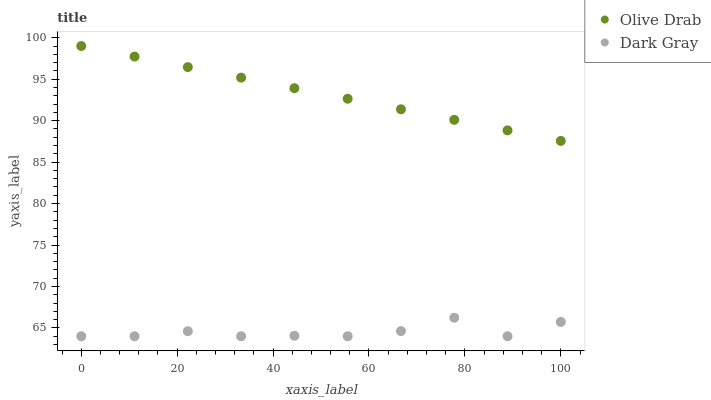Does Dark Gray have the minimum area under the curve?
Answer yes or no. Yes. Does Olive Drab have the maximum area under the curve?
Answer yes or no. Yes. Does Olive Drab have the minimum area under the curve?
Answer yes or no. No. Is Olive Drab the smoothest?
Answer yes or no. Yes. Is Dark Gray the roughest?
Answer yes or no. Yes. Is Olive Drab the roughest?
Answer yes or no. No. Does Dark Gray have the lowest value?
Answer yes or no. Yes. Does Olive Drab have the lowest value?
Answer yes or no. No. Does Olive Drab have the highest value?
Answer yes or no. Yes. Is Dark Gray less than Olive Drab?
Answer yes or no. Yes. Is Olive Drab greater than Dark Gray?
Answer yes or no. Yes. Does Dark Gray intersect Olive Drab?
Answer yes or no. No. 